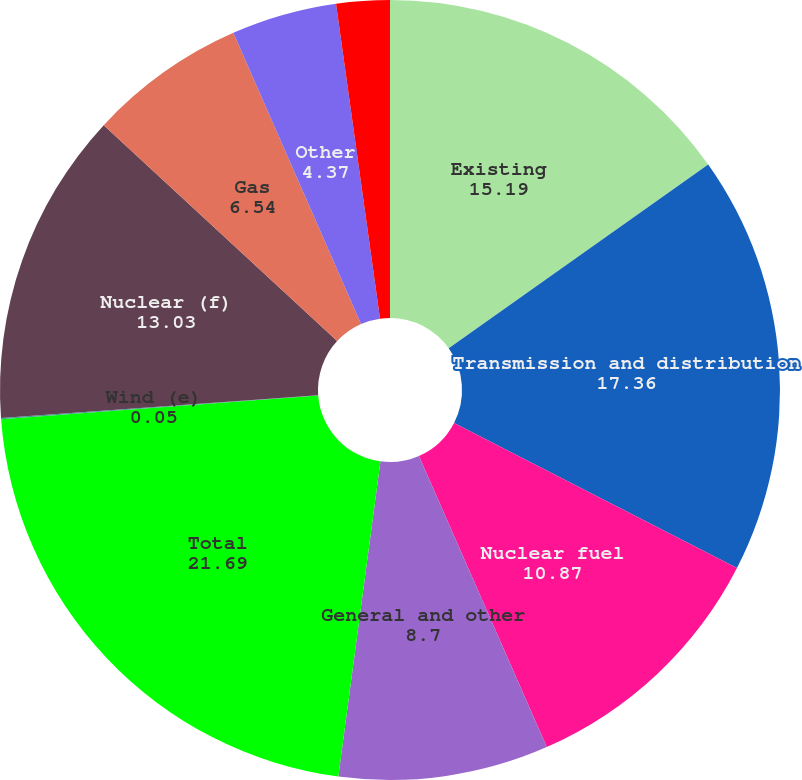Convert chart. <chart><loc_0><loc_0><loc_500><loc_500><pie_chart><fcel>Existing<fcel>Transmission and distribution<fcel>Nuclear fuel<fcel>General and other<fcel>Total<fcel>Wind (e)<fcel>Nuclear (f)<fcel>Gas<fcel>Other<fcel>FPL FiberNet<nl><fcel>15.19%<fcel>17.36%<fcel>10.87%<fcel>8.7%<fcel>21.69%<fcel>0.05%<fcel>13.03%<fcel>6.54%<fcel>4.37%<fcel>2.21%<nl></chart> 